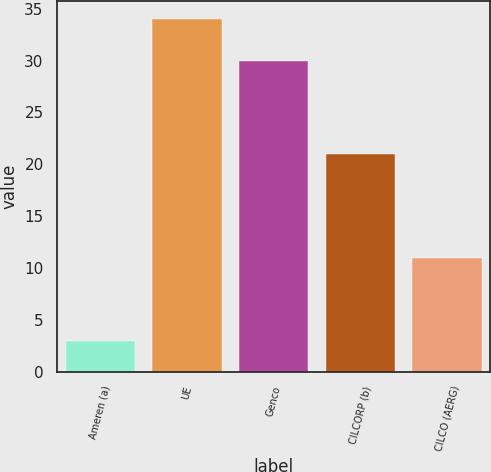Convert chart. <chart><loc_0><loc_0><loc_500><loc_500><bar_chart><fcel>Ameren (a)<fcel>UE<fcel>Genco<fcel>CILCORP (b)<fcel>CILCO (AERG)<nl><fcel>3<fcel>34<fcel>30<fcel>21<fcel>11<nl></chart> 